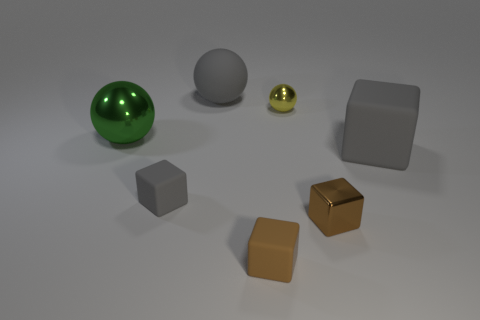Does the shiny sphere to the left of the big gray matte sphere have the same color as the thing behind the tiny yellow sphere?
Your answer should be very brief. No. Is there anything else that has the same color as the rubber ball?
Give a very brief answer. Yes. There is a rubber object behind the cube behind the tiny gray cube; what color is it?
Offer a very short reply. Gray. Are any large cubes visible?
Offer a very short reply. Yes. There is a metal thing that is right of the brown rubber object and left of the tiny brown metallic object; what is its color?
Give a very brief answer. Yellow. Do the metal ball on the right side of the big metal object and the gray matte cube that is right of the brown matte object have the same size?
Your answer should be compact. No. How many other things are the same size as the gray sphere?
Make the answer very short. 2. What number of large gray spheres are behind the rubber thing behind the yellow metallic object?
Your answer should be compact. 0. Is the number of matte spheres on the right side of the metallic cube less than the number of small rubber blocks?
Offer a terse response. Yes. There is a big gray thing on the left side of the large gray object that is in front of the gray matte thing behind the big green thing; what shape is it?
Your answer should be compact. Sphere. 